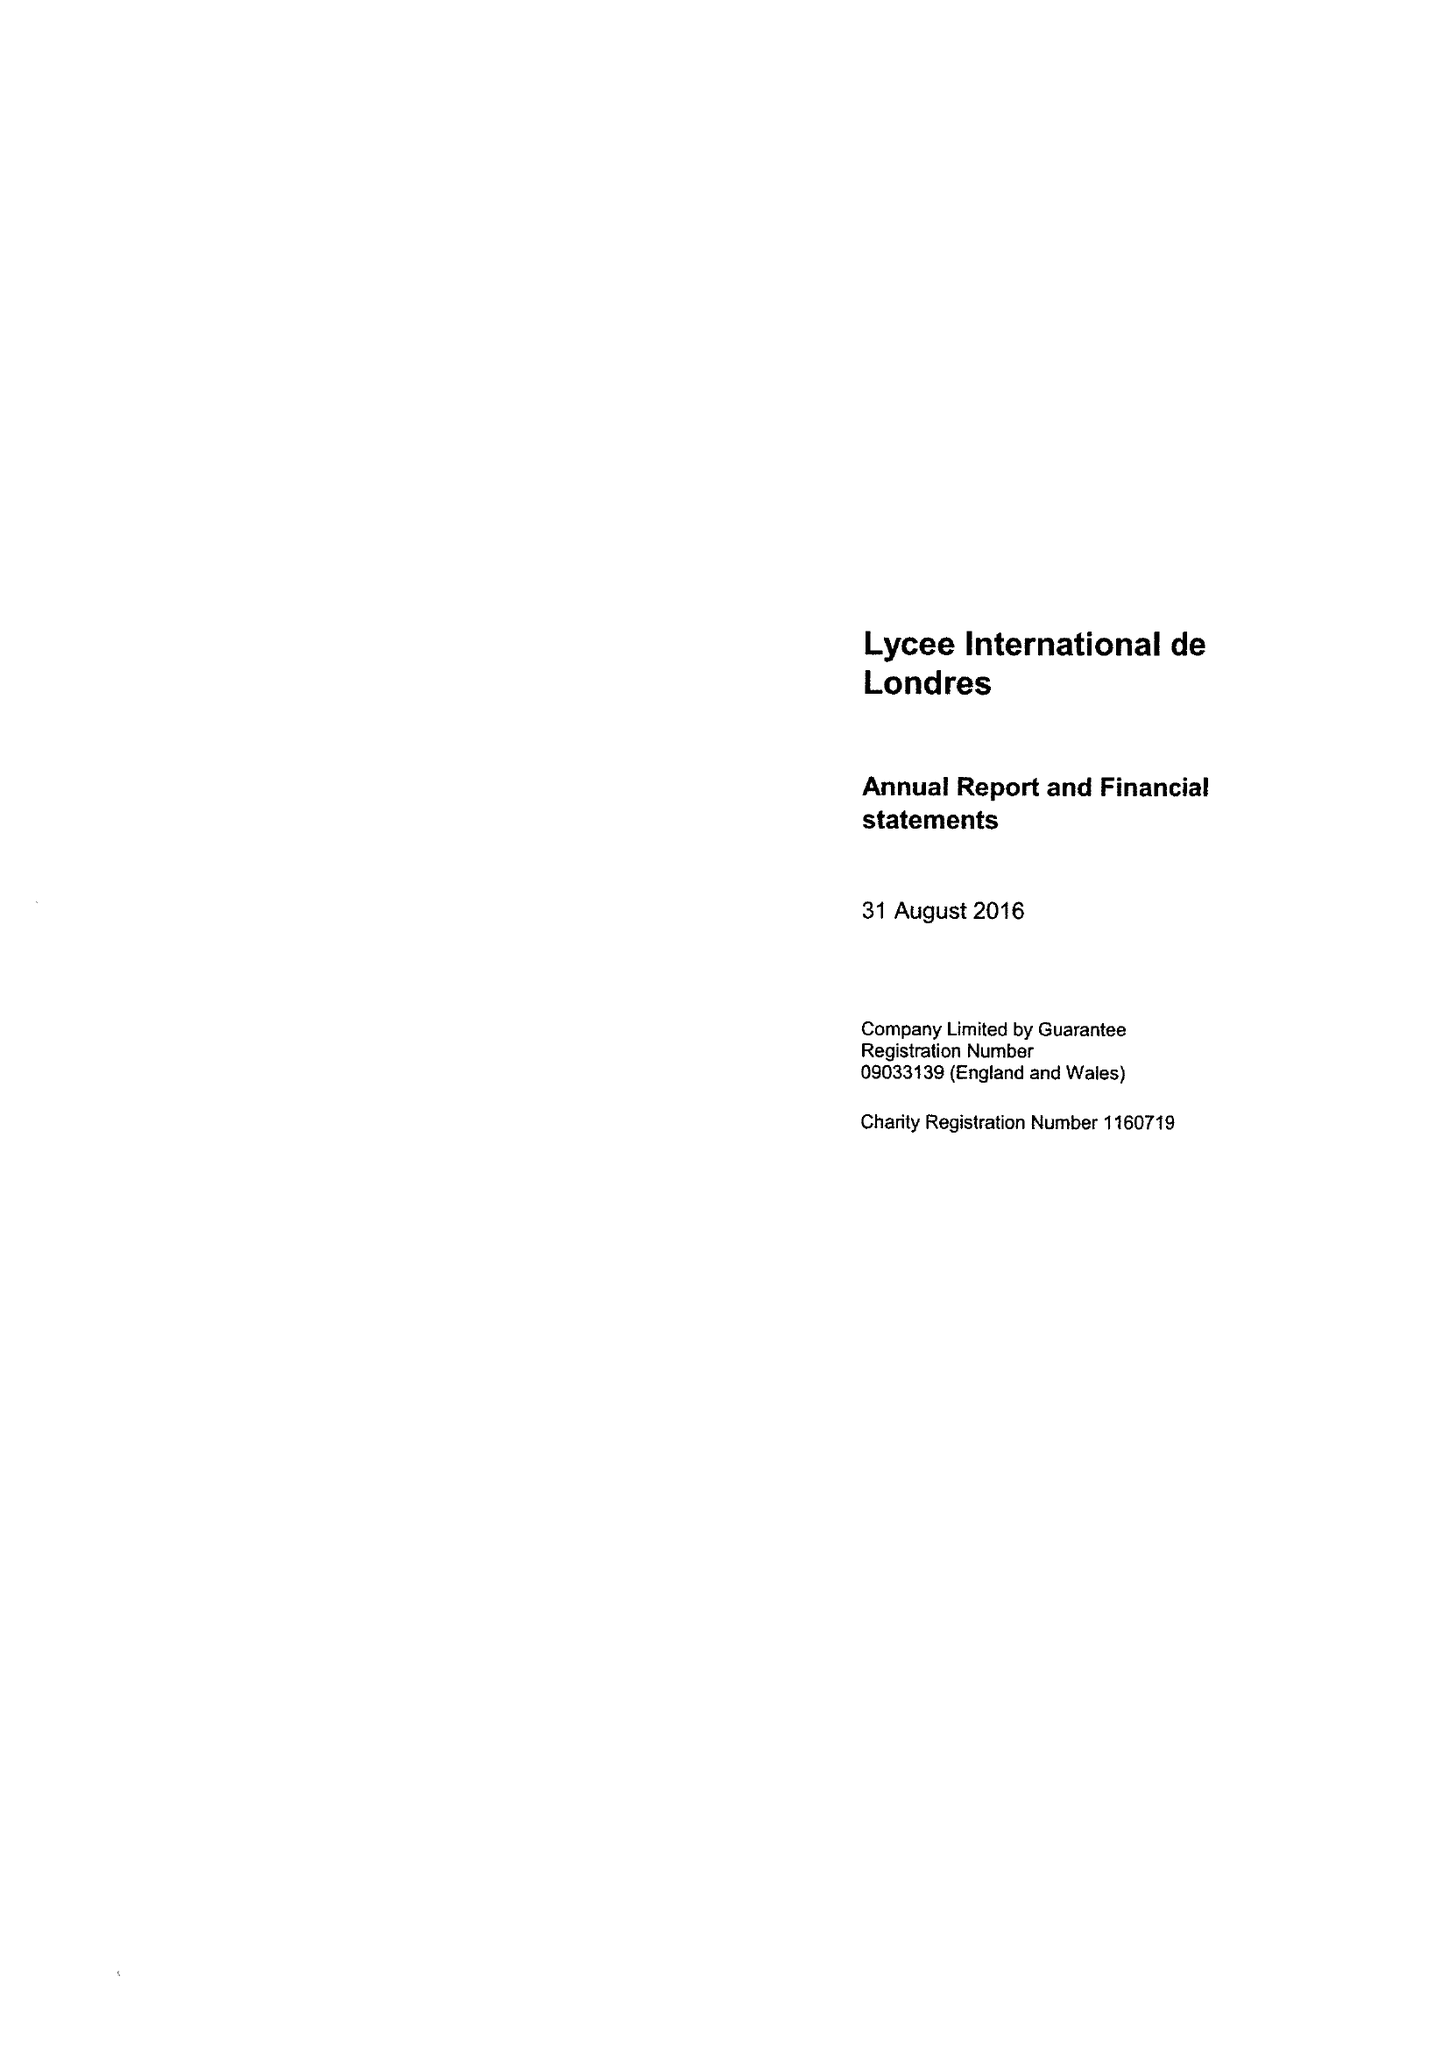What is the value for the income_annually_in_british_pounds?
Answer the question using a single word or phrase. 5269860.00 